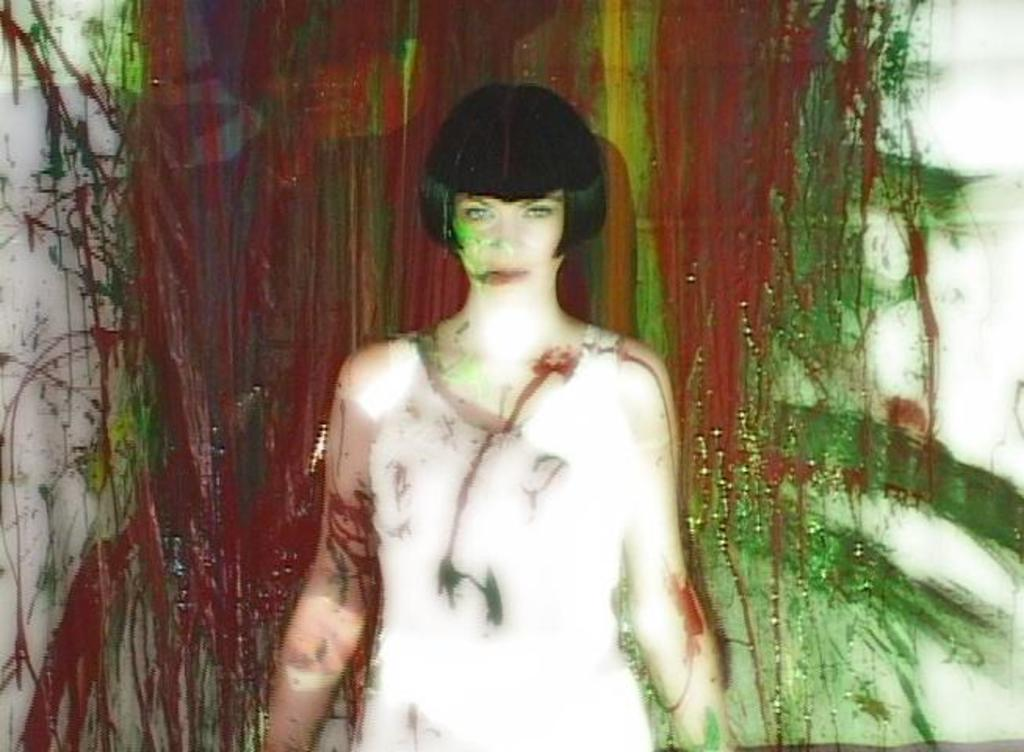Who is the main subject in the image? There is a girl in the center of the image. What can be seen behind the girl? There is a painted wall behind the girl. What type of butter is being used to paint the wall in the image? There is no butter present in the image, and the wall is painted, not covered in butter. How many tomatoes can be seen on the girl's head in the image? There are no tomatoes present in the image, so it is not possible to determine how many would be on the girl's head. 